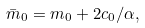<formula> <loc_0><loc_0><loc_500><loc_500>\bar { m } _ { 0 } = m _ { 0 } + 2 c _ { 0 } / \alpha ,</formula> 